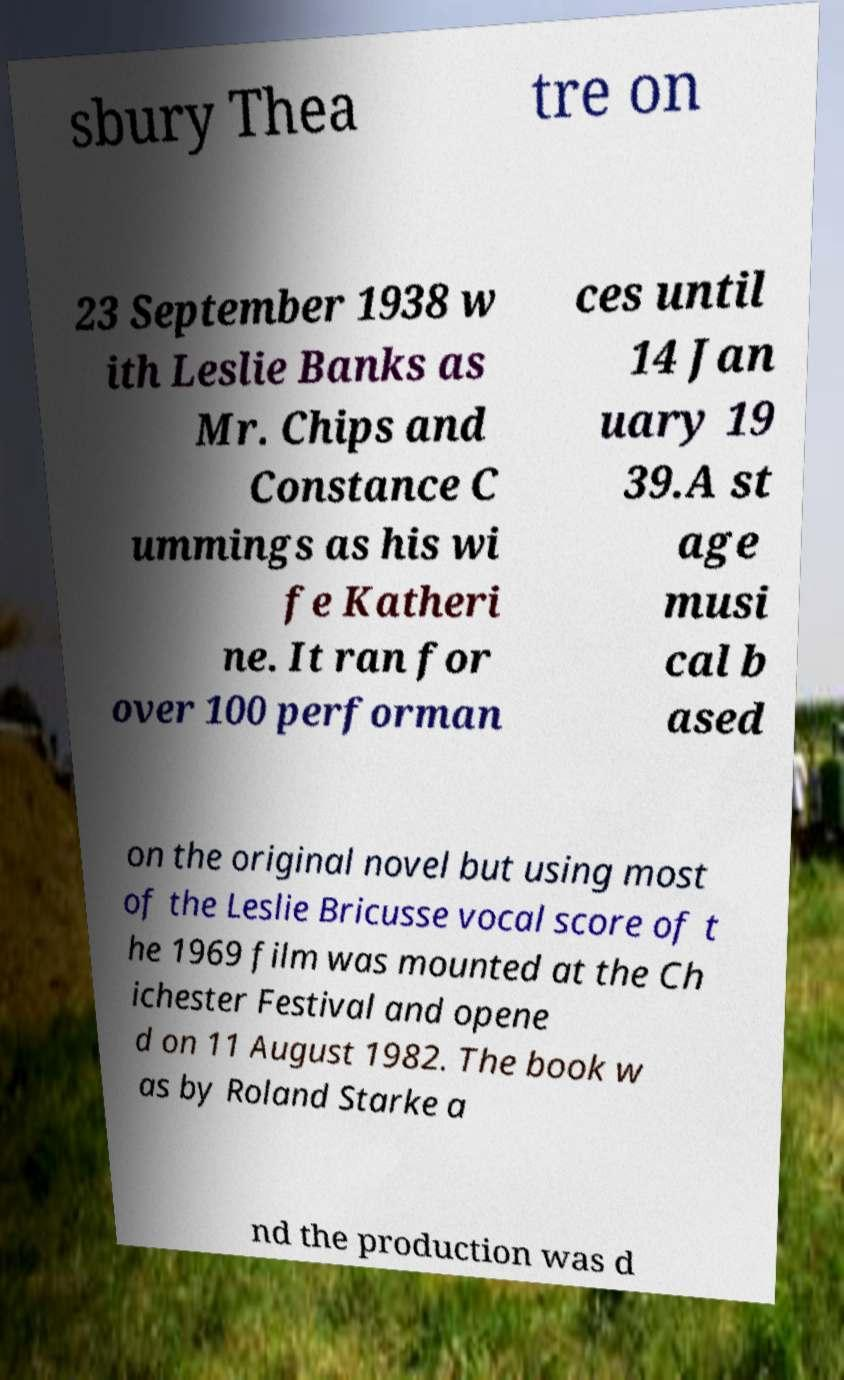Can you read and provide the text displayed in the image?This photo seems to have some interesting text. Can you extract and type it out for me? sbury Thea tre on 23 September 1938 w ith Leslie Banks as Mr. Chips and Constance C ummings as his wi fe Katheri ne. It ran for over 100 performan ces until 14 Jan uary 19 39.A st age musi cal b ased on the original novel but using most of the Leslie Bricusse vocal score of t he 1969 film was mounted at the Ch ichester Festival and opene d on 11 August 1982. The book w as by Roland Starke a nd the production was d 